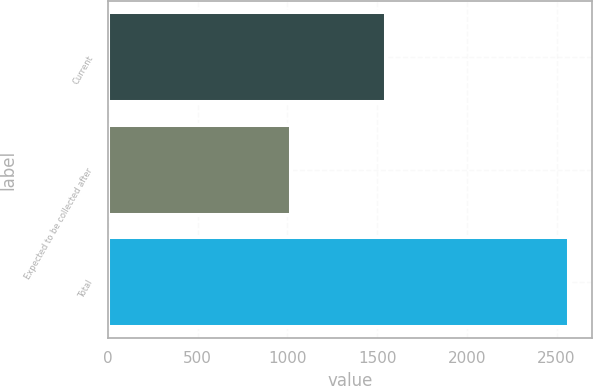Convert chart to OTSL. <chart><loc_0><loc_0><loc_500><loc_500><bar_chart><fcel>Current<fcel>Expected to be collected after<fcel>Total<nl><fcel>1550<fcel>1020<fcel>2570<nl></chart> 